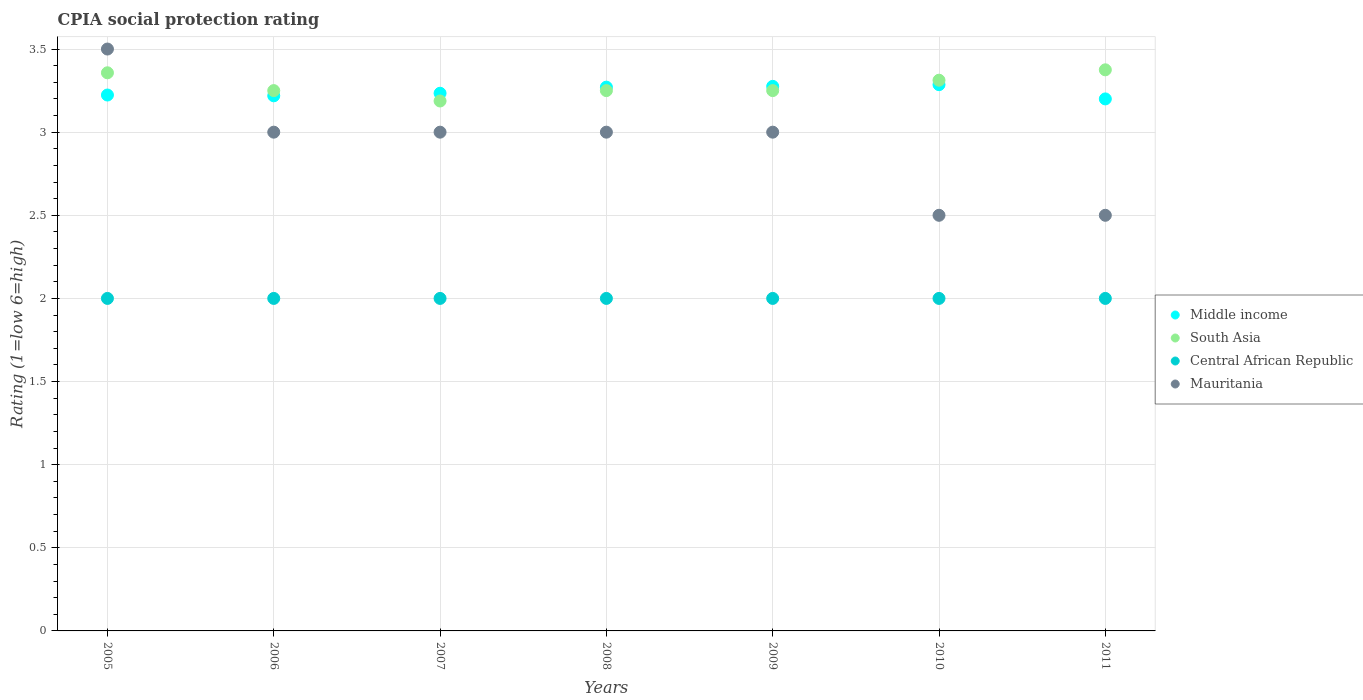How many different coloured dotlines are there?
Provide a succinct answer. 4. What is the CPIA rating in Mauritania in 2006?
Provide a short and direct response. 3. Across all years, what is the maximum CPIA rating in Middle income?
Keep it short and to the point. 3.29. In which year was the CPIA rating in Mauritania maximum?
Your answer should be very brief. 2005. What is the total CPIA rating in South Asia in the graph?
Offer a very short reply. 22.98. What is the difference between the CPIA rating in South Asia in 2009 and that in 2010?
Ensure brevity in your answer.  -0.06. What is the average CPIA rating in South Asia per year?
Provide a short and direct response. 3.28. In the year 2008, what is the difference between the CPIA rating in South Asia and CPIA rating in Middle income?
Provide a succinct answer. -0.02. What is the ratio of the CPIA rating in Central African Republic in 2005 to that in 2011?
Your response must be concise. 1. What is the difference between the highest and the second highest CPIA rating in Mauritania?
Your answer should be very brief. 0.5. What is the difference between the highest and the lowest CPIA rating in South Asia?
Ensure brevity in your answer.  0.19. Is the sum of the CPIA rating in Mauritania in 2006 and 2010 greater than the maximum CPIA rating in South Asia across all years?
Ensure brevity in your answer.  Yes. Is it the case that in every year, the sum of the CPIA rating in Central African Republic and CPIA rating in Mauritania  is greater than the sum of CPIA rating in South Asia and CPIA rating in Middle income?
Make the answer very short. No. Is it the case that in every year, the sum of the CPIA rating in Central African Republic and CPIA rating in Mauritania  is greater than the CPIA rating in South Asia?
Offer a very short reply. Yes. Is the CPIA rating in Mauritania strictly greater than the CPIA rating in Middle income over the years?
Provide a succinct answer. No. Is the CPIA rating in Middle income strictly less than the CPIA rating in South Asia over the years?
Provide a short and direct response. No. Are the values on the major ticks of Y-axis written in scientific E-notation?
Give a very brief answer. No. Where does the legend appear in the graph?
Provide a short and direct response. Center right. How many legend labels are there?
Provide a succinct answer. 4. How are the legend labels stacked?
Offer a very short reply. Vertical. What is the title of the graph?
Offer a terse response. CPIA social protection rating. What is the Rating (1=low 6=high) of Middle income in 2005?
Make the answer very short. 3.22. What is the Rating (1=low 6=high) of South Asia in 2005?
Ensure brevity in your answer.  3.36. What is the Rating (1=low 6=high) in Mauritania in 2005?
Your response must be concise. 3.5. What is the Rating (1=low 6=high) of Middle income in 2006?
Provide a short and direct response. 3.22. What is the Rating (1=low 6=high) of Central African Republic in 2006?
Ensure brevity in your answer.  2. What is the Rating (1=low 6=high) in Middle income in 2007?
Provide a succinct answer. 3.23. What is the Rating (1=low 6=high) in South Asia in 2007?
Ensure brevity in your answer.  3.19. What is the Rating (1=low 6=high) in Central African Republic in 2007?
Your answer should be very brief. 2. What is the Rating (1=low 6=high) in Middle income in 2008?
Make the answer very short. 3.27. What is the Rating (1=low 6=high) in South Asia in 2008?
Keep it short and to the point. 3.25. What is the Rating (1=low 6=high) in Central African Republic in 2008?
Provide a succinct answer. 2. What is the Rating (1=low 6=high) of Mauritania in 2008?
Your answer should be very brief. 3. What is the Rating (1=low 6=high) in Middle income in 2009?
Ensure brevity in your answer.  3.28. What is the Rating (1=low 6=high) in Middle income in 2010?
Keep it short and to the point. 3.29. What is the Rating (1=low 6=high) in South Asia in 2010?
Provide a succinct answer. 3.31. What is the Rating (1=low 6=high) in South Asia in 2011?
Provide a short and direct response. 3.38. What is the Rating (1=low 6=high) of Central African Republic in 2011?
Offer a terse response. 2. What is the Rating (1=low 6=high) of Mauritania in 2011?
Offer a terse response. 2.5. Across all years, what is the maximum Rating (1=low 6=high) of Middle income?
Your answer should be very brief. 3.29. Across all years, what is the maximum Rating (1=low 6=high) of South Asia?
Your answer should be very brief. 3.38. Across all years, what is the minimum Rating (1=low 6=high) in Middle income?
Provide a short and direct response. 3.2. Across all years, what is the minimum Rating (1=low 6=high) of South Asia?
Keep it short and to the point. 3.19. Across all years, what is the minimum Rating (1=low 6=high) in Mauritania?
Offer a terse response. 2.5. What is the total Rating (1=low 6=high) of Middle income in the graph?
Your response must be concise. 22.71. What is the total Rating (1=low 6=high) in South Asia in the graph?
Provide a succinct answer. 22.98. What is the total Rating (1=low 6=high) of Central African Republic in the graph?
Provide a short and direct response. 14. What is the total Rating (1=low 6=high) of Mauritania in the graph?
Offer a very short reply. 20.5. What is the difference between the Rating (1=low 6=high) in Middle income in 2005 and that in 2006?
Offer a terse response. 0. What is the difference between the Rating (1=low 6=high) in South Asia in 2005 and that in 2006?
Your answer should be compact. 0.11. What is the difference between the Rating (1=low 6=high) of Middle income in 2005 and that in 2007?
Offer a terse response. -0.01. What is the difference between the Rating (1=low 6=high) in South Asia in 2005 and that in 2007?
Ensure brevity in your answer.  0.17. What is the difference between the Rating (1=low 6=high) in Middle income in 2005 and that in 2008?
Your answer should be compact. -0.05. What is the difference between the Rating (1=low 6=high) in South Asia in 2005 and that in 2008?
Make the answer very short. 0.11. What is the difference between the Rating (1=low 6=high) in Central African Republic in 2005 and that in 2008?
Keep it short and to the point. 0. What is the difference between the Rating (1=low 6=high) in Middle income in 2005 and that in 2009?
Make the answer very short. -0.05. What is the difference between the Rating (1=low 6=high) of South Asia in 2005 and that in 2009?
Make the answer very short. 0.11. What is the difference between the Rating (1=low 6=high) of Central African Republic in 2005 and that in 2009?
Provide a succinct answer. 0. What is the difference between the Rating (1=low 6=high) in Mauritania in 2005 and that in 2009?
Give a very brief answer. 0.5. What is the difference between the Rating (1=low 6=high) of Middle income in 2005 and that in 2010?
Keep it short and to the point. -0.06. What is the difference between the Rating (1=low 6=high) of South Asia in 2005 and that in 2010?
Offer a terse response. 0.04. What is the difference between the Rating (1=low 6=high) of Central African Republic in 2005 and that in 2010?
Ensure brevity in your answer.  0. What is the difference between the Rating (1=low 6=high) of Mauritania in 2005 and that in 2010?
Your answer should be very brief. 1. What is the difference between the Rating (1=low 6=high) of Middle income in 2005 and that in 2011?
Offer a very short reply. 0.02. What is the difference between the Rating (1=low 6=high) of South Asia in 2005 and that in 2011?
Ensure brevity in your answer.  -0.02. What is the difference between the Rating (1=low 6=high) in Central African Republic in 2005 and that in 2011?
Ensure brevity in your answer.  0. What is the difference between the Rating (1=low 6=high) in Middle income in 2006 and that in 2007?
Keep it short and to the point. -0.02. What is the difference between the Rating (1=low 6=high) in South Asia in 2006 and that in 2007?
Offer a terse response. 0.06. What is the difference between the Rating (1=low 6=high) of Mauritania in 2006 and that in 2007?
Provide a short and direct response. 0. What is the difference between the Rating (1=low 6=high) in Middle income in 2006 and that in 2008?
Make the answer very short. -0.05. What is the difference between the Rating (1=low 6=high) of Central African Republic in 2006 and that in 2008?
Offer a very short reply. 0. What is the difference between the Rating (1=low 6=high) of Mauritania in 2006 and that in 2008?
Give a very brief answer. 0. What is the difference between the Rating (1=low 6=high) of Middle income in 2006 and that in 2009?
Give a very brief answer. -0.06. What is the difference between the Rating (1=low 6=high) of South Asia in 2006 and that in 2009?
Keep it short and to the point. 0. What is the difference between the Rating (1=low 6=high) in Mauritania in 2006 and that in 2009?
Provide a short and direct response. 0. What is the difference between the Rating (1=low 6=high) in Middle income in 2006 and that in 2010?
Offer a terse response. -0.07. What is the difference between the Rating (1=low 6=high) of South Asia in 2006 and that in 2010?
Your answer should be very brief. -0.06. What is the difference between the Rating (1=low 6=high) in Middle income in 2006 and that in 2011?
Ensure brevity in your answer.  0.02. What is the difference between the Rating (1=low 6=high) in South Asia in 2006 and that in 2011?
Keep it short and to the point. -0.12. What is the difference between the Rating (1=low 6=high) in Central African Republic in 2006 and that in 2011?
Your answer should be very brief. 0. What is the difference between the Rating (1=low 6=high) in Middle income in 2007 and that in 2008?
Your answer should be compact. -0.04. What is the difference between the Rating (1=low 6=high) of South Asia in 2007 and that in 2008?
Give a very brief answer. -0.06. What is the difference between the Rating (1=low 6=high) in Central African Republic in 2007 and that in 2008?
Provide a short and direct response. 0. What is the difference between the Rating (1=low 6=high) in Middle income in 2007 and that in 2009?
Ensure brevity in your answer.  -0.04. What is the difference between the Rating (1=low 6=high) of South Asia in 2007 and that in 2009?
Ensure brevity in your answer.  -0.06. What is the difference between the Rating (1=low 6=high) of Mauritania in 2007 and that in 2009?
Keep it short and to the point. 0. What is the difference between the Rating (1=low 6=high) in Middle income in 2007 and that in 2010?
Provide a succinct answer. -0.05. What is the difference between the Rating (1=low 6=high) in South Asia in 2007 and that in 2010?
Provide a short and direct response. -0.12. What is the difference between the Rating (1=low 6=high) in Central African Republic in 2007 and that in 2010?
Provide a succinct answer. 0. What is the difference between the Rating (1=low 6=high) of Mauritania in 2007 and that in 2010?
Provide a succinct answer. 0.5. What is the difference between the Rating (1=low 6=high) in Middle income in 2007 and that in 2011?
Your answer should be compact. 0.03. What is the difference between the Rating (1=low 6=high) of South Asia in 2007 and that in 2011?
Offer a terse response. -0.19. What is the difference between the Rating (1=low 6=high) of Mauritania in 2007 and that in 2011?
Your response must be concise. 0.5. What is the difference between the Rating (1=low 6=high) in Middle income in 2008 and that in 2009?
Provide a succinct answer. -0. What is the difference between the Rating (1=low 6=high) of South Asia in 2008 and that in 2009?
Offer a terse response. 0. What is the difference between the Rating (1=low 6=high) in Central African Republic in 2008 and that in 2009?
Your answer should be very brief. 0. What is the difference between the Rating (1=low 6=high) in Middle income in 2008 and that in 2010?
Provide a short and direct response. -0.01. What is the difference between the Rating (1=low 6=high) of South Asia in 2008 and that in 2010?
Your answer should be compact. -0.06. What is the difference between the Rating (1=low 6=high) of Central African Republic in 2008 and that in 2010?
Make the answer very short. 0. What is the difference between the Rating (1=low 6=high) of Middle income in 2008 and that in 2011?
Your response must be concise. 0.07. What is the difference between the Rating (1=low 6=high) in South Asia in 2008 and that in 2011?
Your answer should be compact. -0.12. What is the difference between the Rating (1=low 6=high) in Middle income in 2009 and that in 2010?
Offer a very short reply. -0.01. What is the difference between the Rating (1=low 6=high) of South Asia in 2009 and that in 2010?
Provide a succinct answer. -0.06. What is the difference between the Rating (1=low 6=high) in Central African Republic in 2009 and that in 2010?
Provide a succinct answer. 0. What is the difference between the Rating (1=low 6=high) in Mauritania in 2009 and that in 2010?
Provide a short and direct response. 0.5. What is the difference between the Rating (1=low 6=high) in Middle income in 2009 and that in 2011?
Provide a succinct answer. 0.08. What is the difference between the Rating (1=low 6=high) in South Asia in 2009 and that in 2011?
Offer a very short reply. -0.12. What is the difference between the Rating (1=low 6=high) of Central African Republic in 2009 and that in 2011?
Your answer should be compact. 0. What is the difference between the Rating (1=low 6=high) of Middle income in 2010 and that in 2011?
Your answer should be compact. 0.09. What is the difference between the Rating (1=low 6=high) in South Asia in 2010 and that in 2011?
Your answer should be very brief. -0.06. What is the difference between the Rating (1=low 6=high) of Central African Republic in 2010 and that in 2011?
Your answer should be very brief. 0. What is the difference between the Rating (1=low 6=high) in Mauritania in 2010 and that in 2011?
Give a very brief answer. 0. What is the difference between the Rating (1=low 6=high) of Middle income in 2005 and the Rating (1=low 6=high) of South Asia in 2006?
Provide a succinct answer. -0.03. What is the difference between the Rating (1=low 6=high) in Middle income in 2005 and the Rating (1=low 6=high) in Central African Republic in 2006?
Make the answer very short. 1.22. What is the difference between the Rating (1=low 6=high) in Middle income in 2005 and the Rating (1=low 6=high) in Mauritania in 2006?
Offer a very short reply. 0.22. What is the difference between the Rating (1=low 6=high) in South Asia in 2005 and the Rating (1=low 6=high) in Central African Republic in 2006?
Offer a very short reply. 1.36. What is the difference between the Rating (1=low 6=high) of South Asia in 2005 and the Rating (1=low 6=high) of Mauritania in 2006?
Give a very brief answer. 0.36. What is the difference between the Rating (1=low 6=high) of Central African Republic in 2005 and the Rating (1=low 6=high) of Mauritania in 2006?
Your answer should be compact. -1. What is the difference between the Rating (1=low 6=high) in Middle income in 2005 and the Rating (1=low 6=high) in South Asia in 2007?
Provide a succinct answer. 0.04. What is the difference between the Rating (1=low 6=high) in Middle income in 2005 and the Rating (1=low 6=high) in Central African Republic in 2007?
Your answer should be very brief. 1.22. What is the difference between the Rating (1=low 6=high) of Middle income in 2005 and the Rating (1=low 6=high) of Mauritania in 2007?
Provide a succinct answer. 0.22. What is the difference between the Rating (1=low 6=high) in South Asia in 2005 and the Rating (1=low 6=high) in Central African Republic in 2007?
Provide a succinct answer. 1.36. What is the difference between the Rating (1=low 6=high) of South Asia in 2005 and the Rating (1=low 6=high) of Mauritania in 2007?
Provide a succinct answer. 0.36. What is the difference between the Rating (1=low 6=high) in Middle income in 2005 and the Rating (1=low 6=high) in South Asia in 2008?
Offer a very short reply. -0.03. What is the difference between the Rating (1=low 6=high) in Middle income in 2005 and the Rating (1=low 6=high) in Central African Republic in 2008?
Give a very brief answer. 1.22. What is the difference between the Rating (1=low 6=high) of Middle income in 2005 and the Rating (1=low 6=high) of Mauritania in 2008?
Your answer should be compact. 0.22. What is the difference between the Rating (1=low 6=high) in South Asia in 2005 and the Rating (1=low 6=high) in Central African Republic in 2008?
Your response must be concise. 1.36. What is the difference between the Rating (1=low 6=high) in South Asia in 2005 and the Rating (1=low 6=high) in Mauritania in 2008?
Provide a succinct answer. 0.36. What is the difference between the Rating (1=low 6=high) in Middle income in 2005 and the Rating (1=low 6=high) in South Asia in 2009?
Your response must be concise. -0.03. What is the difference between the Rating (1=low 6=high) of Middle income in 2005 and the Rating (1=low 6=high) of Central African Republic in 2009?
Provide a succinct answer. 1.22. What is the difference between the Rating (1=low 6=high) in Middle income in 2005 and the Rating (1=low 6=high) in Mauritania in 2009?
Your answer should be very brief. 0.22. What is the difference between the Rating (1=low 6=high) in South Asia in 2005 and the Rating (1=low 6=high) in Central African Republic in 2009?
Give a very brief answer. 1.36. What is the difference between the Rating (1=low 6=high) in South Asia in 2005 and the Rating (1=low 6=high) in Mauritania in 2009?
Offer a very short reply. 0.36. What is the difference between the Rating (1=low 6=high) in Central African Republic in 2005 and the Rating (1=low 6=high) in Mauritania in 2009?
Offer a very short reply. -1. What is the difference between the Rating (1=low 6=high) in Middle income in 2005 and the Rating (1=low 6=high) in South Asia in 2010?
Your response must be concise. -0.09. What is the difference between the Rating (1=low 6=high) of Middle income in 2005 and the Rating (1=low 6=high) of Central African Republic in 2010?
Give a very brief answer. 1.22. What is the difference between the Rating (1=low 6=high) of Middle income in 2005 and the Rating (1=low 6=high) of Mauritania in 2010?
Give a very brief answer. 0.72. What is the difference between the Rating (1=low 6=high) in South Asia in 2005 and the Rating (1=low 6=high) in Central African Republic in 2010?
Your response must be concise. 1.36. What is the difference between the Rating (1=low 6=high) in South Asia in 2005 and the Rating (1=low 6=high) in Mauritania in 2010?
Your answer should be very brief. 0.86. What is the difference between the Rating (1=low 6=high) of Middle income in 2005 and the Rating (1=low 6=high) of South Asia in 2011?
Your response must be concise. -0.15. What is the difference between the Rating (1=low 6=high) of Middle income in 2005 and the Rating (1=low 6=high) of Central African Republic in 2011?
Your answer should be compact. 1.22. What is the difference between the Rating (1=low 6=high) in Middle income in 2005 and the Rating (1=low 6=high) in Mauritania in 2011?
Give a very brief answer. 0.72. What is the difference between the Rating (1=low 6=high) in South Asia in 2005 and the Rating (1=low 6=high) in Central African Republic in 2011?
Your answer should be compact. 1.36. What is the difference between the Rating (1=low 6=high) of Central African Republic in 2005 and the Rating (1=low 6=high) of Mauritania in 2011?
Offer a terse response. -0.5. What is the difference between the Rating (1=low 6=high) in Middle income in 2006 and the Rating (1=low 6=high) in South Asia in 2007?
Your response must be concise. 0.03. What is the difference between the Rating (1=low 6=high) in Middle income in 2006 and the Rating (1=low 6=high) in Central African Republic in 2007?
Give a very brief answer. 1.22. What is the difference between the Rating (1=low 6=high) in Middle income in 2006 and the Rating (1=low 6=high) in Mauritania in 2007?
Your response must be concise. 0.22. What is the difference between the Rating (1=low 6=high) of South Asia in 2006 and the Rating (1=low 6=high) of Mauritania in 2007?
Give a very brief answer. 0.25. What is the difference between the Rating (1=low 6=high) of Middle income in 2006 and the Rating (1=low 6=high) of South Asia in 2008?
Your answer should be compact. -0.03. What is the difference between the Rating (1=low 6=high) in Middle income in 2006 and the Rating (1=low 6=high) in Central African Republic in 2008?
Your answer should be compact. 1.22. What is the difference between the Rating (1=low 6=high) in Middle income in 2006 and the Rating (1=low 6=high) in Mauritania in 2008?
Keep it short and to the point. 0.22. What is the difference between the Rating (1=low 6=high) of South Asia in 2006 and the Rating (1=low 6=high) of Central African Republic in 2008?
Your answer should be very brief. 1.25. What is the difference between the Rating (1=low 6=high) in Central African Republic in 2006 and the Rating (1=low 6=high) in Mauritania in 2008?
Your answer should be compact. -1. What is the difference between the Rating (1=low 6=high) of Middle income in 2006 and the Rating (1=low 6=high) of South Asia in 2009?
Provide a short and direct response. -0.03. What is the difference between the Rating (1=low 6=high) in Middle income in 2006 and the Rating (1=low 6=high) in Central African Republic in 2009?
Your response must be concise. 1.22. What is the difference between the Rating (1=low 6=high) of Middle income in 2006 and the Rating (1=low 6=high) of Mauritania in 2009?
Your response must be concise. 0.22. What is the difference between the Rating (1=low 6=high) in South Asia in 2006 and the Rating (1=low 6=high) in Mauritania in 2009?
Give a very brief answer. 0.25. What is the difference between the Rating (1=low 6=high) in Central African Republic in 2006 and the Rating (1=low 6=high) in Mauritania in 2009?
Provide a succinct answer. -1. What is the difference between the Rating (1=low 6=high) in Middle income in 2006 and the Rating (1=low 6=high) in South Asia in 2010?
Offer a very short reply. -0.09. What is the difference between the Rating (1=low 6=high) of Middle income in 2006 and the Rating (1=low 6=high) of Central African Republic in 2010?
Ensure brevity in your answer.  1.22. What is the difference between the Rating (1=low 6=high) of Middle income in 2006 and the Rating (1=low 6=high) of Mauritania in 2010?
Provide a succinct answer. 0.72. What is the difference between the Rating (1=low 6=high) of Central African Republic in 2006 and the Rating (1=low 6=high) of Mauritania in 2010?
Offer a terse response. -0.5. What is the difference between the Rating (1=low 6=high) in Middle income in 2006 and the Rating (1=low 6=high) in South Asia in 2011?
Ensure brevity in your answer.  -0.16. What is the difference between the Rating (1=low 6=high) of Middle income in 2006 and the Rating (1=low 6=high) of Central African Republic in 2011?
Provide a short and direct response. 1.22. What is the difference between the Rating (1=low 6=high) in Middle income in 2006 and the Rating (1=low 6=high) in Mauritania in 2011?
Give a very brief answer. 0.72. What is the difference between the Rating (1=low 6=high) in South Asia in 2006 and the Rating (1=low 6=high) in Central African Republic in 2011?
Your answer should be very brief. 1.25. What is the difference between the Rating (1=low 6=high) in South Asia in 2006 and the Rating (1=low 6=high) in Mauritania in 2011?
Ensure brevity in your answer.  0.75. What is the difference between the Rating (1=low 6=high) in Middle income in 2007 and the Rating (1=low 6=high) in South Asia in 2008?
Provide a short and direct response. -0.02. What is the difference between the Rating (1=low 6=high) in Middle income in 2007 and the Rating (1=low 6=high) in Central African Republic in 2008?
Make the answer very short. 1.23. What is the difference between the Rating (1=low 6=high) of Middle income in 2007 and the Rating (1=low 6=high) of Mauritania in 2008?
Offer a terse response. 0.23. What is the difference between the Rating (1=low 6=high) in South Asia in 2007 and the Rating (1=low 6=high) in Central African Republic in 2008?
Your answer should be compact. 1.19. What is the difference between the Rating (1=low 6=high) of South Asia in 2007 and the Rating (1=low 6=high) of Mauritania in 2008?
Ensure brevity in your answer.  0.19. What is the difference between the Rating (1=low 6=high) in Middle income in 2007 and the Rating (1=low 6=high) in South Asia in 2009?
Provide a succinct answer. -0.02. What is the difference between the Rating (1=low 6=high) of Middle income in 2007 and the Rating (1=low 6=high) of Central African Republic in 2009?
Provide a short and direct response. 1.23. What is the difference between the Rating (1=low 6=high) in Middle income in 2007 and the Rating (1=low 6=high) in Mauritania in 2009?
Provide a short and direct response. 0.23. What is the difference between the Rating (1=low 6=high) in South Asia in 2007 and the Rating (1=low 6=high) in Central African Republic in 2009?
Your answer should be very brief. 1.19. What is the difference between the Rating (1=low 6=high) of South Asia in 2007 and the Rating (1=low 6=high) of Mauritania in 2009?
Your answer should be very brief. 0.19. What is the difference between the Rating (1=low 6=high) in Central African Republic in 2007 and the Rating (1=low 6=high) in Mauritania in 2009?
Provide a succinct answer. -1. What is the difference between the Rating (1=low 6=high) in Middle income in 2007 and the Rating (1=low 6=high) in South Asia in 2010?
Provide a succinct answer. -0.08. What is the difference between the Rating (1=low 6=high) of Middle income in 2007 and the Rating (1=low 6=high) of Central African Republic in 2010?
Provide a succinct answer. 1.23. What is the difference between the Rating (1=low 6=high) of Middle income in 2007 and the Rating (1=low 6=high) of Mauritania in 2010?
Provide a succinct answer. 0.73. What is the difference between the Rating (1=low 6=high) in South Asia in 2007 and the Rating (1=low 6=high) in Central African Republic in 2010?
Your response must be concise. 1.19. What is the difference between the Rating (1=low 6=high) of South Asia in 2007 and the Rating (1=low 6=high) of Mauritania in 2010?
Your response must be concise. 0.69. What is the difference between the Rating (1=low 6=high) of Central African Republic in 2007 and the Rating (1=low 6=high) of Mauritania in 2010?
Provide a succinct answer. -0.5. What is the difference between the Rating (1=low 6=high) of Middle income in 2007 and the Rating (1=low 6=high) of South Asia in 2011?
Your response must be concise. -0.14. What is the difference between the Rating (1=low 6=high) of Middle income in 2007 and the Rating (1=low 6=high) of Central African Republic in 2011?
Make the answer very short. 1.23. What is the difference between the Rating (1=low 6=high) of Middle income in 2007 and the Rating (1=low 6=high) of Mauritania in 2011?
Make the answer very short. 0.73. What is the difference between the Rating (1=low 6=high) in South Asia in 2007 and the Rating (1=low 6=high) in Central African Republic in 2011?
Your response must be concise. 1.19. What is the difference between the Rating (1=low 6=high) in South Asia in 2007 and the Rating (1=low 6=high) in Mauritania in 2011?
Your answer should be very brief. 0.69. What is the difference between the Rating (1=low 6=high) of Middle income in 2008 and the Rating (1=low 6=high) of South Asia in 2009?
Make the answer very short. 0.02. What is the difference between the Rating (1=low 6=high) in Middle income in 2008 and the Rating (1=low 6=high) in Central African Republic in 2009?
Your answer should be very brief. 1.27. What is the difference between the Rating (1=low 6=high) in Middle income in 2008 and the Rating (1=low 6=high) in Mauritania in 2009?
Ensure brevity in your answer.  0.27. What is the difference between the Rating (1=low 6=high) in South Asia in 2008 and the Rating (1=low 6=high) in Mauritania in 2009?
Keep it short and to the point. 0.25. What is the difference between the Rating (1=low 6=high) in Central African Republic in 2008 and the Rating (1=low 6=high) in Mauritania in 2009?
Provide a succinct answer. -1. What is the difference between the Rating (1=low 6=high) of Middle income in 2008 and the Rating (1=low 6=high) of South Asia in 2010?
Your response must be concise. -0.04. What is the difference between the Rating (1=low 6=high) of Middle income in 2008 and the Rating (1=low 6=high) of Central African Republic in 2010?
Give a very brief answer. 1.27. What is the difference between the Rating (1=low 6=high) of Middle income in 2008 and the Rating (1=low 6=high) of Mauritania in 2010?
Keep it short and to the point. 0.77. What is the difference between the Rating (1=low 6=high) in South Asia in 2008 and the Rating (1=low 6=high) in Central African Republic in 2010?
Your answer should be very brief. 1.25. What is the difference between the Rating (1=low 6=high) of South Asia in 2008 and the Rating (1=low 6=high) of Mauritania in 2010?
Make the answer very short. 0.75. What is the difference between the Rating (1=low 6=high) in Middle income in 2008 and the Rating (1=low 6=high) in South Asia in 2011?
Keep it short and to the point. -0.1. What is the difference between the Rating (1=low 6=high) in Middle income in 2008 and the Rating (1=low 6=high) in Central African Republic in 2011?
Your answer should be compact. 1.27. What is the difference between the Rating (1=low 6=high) of Middle income in 2008 and the Rating (1=low 6=high) of Mauritania in 2011?
Your answer should be compact. 0.77. What is the difference between the Rating (1=low 6=high) of South Asia in 2008 and the Rating (1=low 6=high) of Central African Republic in 2011?
Offer a very short reply. 1.25. What is the difference between the Rating (1=low 6=high) in South Asia in 2008 and the Rating (1=low 6=high) in Mauritania in 2011?
Offer a very short reply. 0.75. What is the difference between the Rating (1=low 6=high) of Middle income in 2009 and the Rating (1=low 6=high) of South Asia in 2010?
Your response must be concise. -0.04. What is the difference between the Rating (1=low 6=high) of Middle income in 2009 and the Rating (1=low 6=high) of Central African Republic in 2010?
Keep it short and to the point. 1.28. What is the difference between the Rating (1=low 6=high) of Middle income in 2009 and the Rating (1=low 6=high) of Mauritania in 2010?
Offer a terse response. 0.78. What is the difference between the Rating (1=low 6=high) in South Asia in 2009 and the Rating (1=low 6=high) in Central African Republic in 2010?
Your response must be concise. 1.25. What is the difference between the Rating (1=low 6=high) in South Asia in 2009 and the Rating (1=low 6=high) in Mauritania in 2010?
Provide a succinct answer. 0.75. What is the difference between the Rating (1=low 6=high) of Central African Republic in 2009 and the Rating (1=low 6=high) of Mauritania in 2010?
Offer a very short reply. -0.5. What is the difference between the Rating (1=low 6=high) in Middle income in 2009 and the Rating (1=low 6=high) in South Asia in 2011?
Provide a short and direct response. -0.1. What is the difference between the Rating (1=low 6=high) in Middle income in 2009 and the Rating (1=low 6=high) in Central African Republic in 2011?
Provide a succinct answer. 1.28. What is the difference between the Rating (1=low 6=high) in Middle income in 2009 and the Rating (1=low 6=high) in Mauritania in 2011?
Your answer should be very brief. 0.78. What is the difference between the Rating (1=low 6=high) of South Asia in 2009 and the Rating (1=low 6=high) of Central African Republic in 2011?
Your answer should be compact. 1.25. What is the difference between the Rating (1=low 6=high) of Middle income in 2010 and the Rating (1=low 6=high) of South Asia in 2011?
Keep it short and to the point. -0.09. What is the difference between the Rating (1=low 6=high) in Middle income in 2010 and the Rating (1=low 6=high) in Mauritania in 2011?
Provide a short and direct response. 0.79. What is the difference between the Rating (1=low 6=high) in South Asia in 2010 and the Rating (1=low 6=high) in Central African Republic in 2011?
Ensure brevity in your answer.  1.31. What is the difference between the Rating (1=low 6=high) in South Asia in 2010 and the Rating (1=low 6=high) in Mauritania in 2011?
Make the answer very short. 0.81. What is the average Rating (1=low 6=high) in Middle income per year?
Make the answer very short. 3.24. What is the average Rating (1=low 6=high) in South Asia per year?
Offer a very short reply. 3.28. What is the average Rating (1=low 6=high) of Mauritania per year?
Your answer should be very brief. 2.93. In the year 2005, what is the difference between the Rating (1=low 6=high) in Middle income and Rating (1=low 6=high) in South Asia?
Provide a succinct answer. -0.13. In the year 2005, what is the difference between the Rating (1=low 6=high) of Middle income and Rating (1=low 6=high) of Central African Republic?
Your response must be concise. 1.22. In the year 2005, what is the difference between the Rating (1=low 6=high) in Middle income and Rating (1=low 6=high) in Mauritania?
Your response must be concise. -0.28. In the year 2005, what is the difference between the Rating (1=low 6=high) of South Asia and Rating (1=low 6=high) of Central African Republic?
Offer a very short reply. 1.36. In the year 2005, what is the difference between the Rating (1=low 6=high) of South Asia and Rating (1=low 6=high) of Mauritania?
Give a very brief answer. -0.14. In the year 2006, what is the difference between the Rating (1=low 6=high) in Middle income and Rating (1=low 6=high) in South Asia?
Provide a succinct answer. -0.03. In the year 2006, what is the difference between the Rating (1=low 6=high) in Middle income and Rating (1=low 6=high) in Central African Republic?
Provide a short and direct response. 1.22. In the year 2006, what is the difference between the Rating (1=low 6=high) of Middle income and Rating (1=low 6=high) of Mauritania?
Offer a terse response. 0.22. In the year 2006, what is the difference between the Rating (1=low 6=high) of Central African Republic and Rating (1=low 6=high) of Mauritania?
Your answer should be very brief. -1. In the year 2007, what is the difference between the Rating (1=low 6=high) of Middle income and Rating (1=low 6=high) of South Asia?
Your answer should be very brief. 0.05. In the year 2007, what is the difference between the Rating (1=low 6=high) of Middle income and Rating (1=low 6=high) of Central African Republic?
Offer a very short reply. 1.23. In the year 2007, what is the difference between the Rating (1=low 6=high) in Middle income and Rating (1=low 6=high) in Mauritania?
Make the answer very short. 0.23. In the year 2007, what is the difference between the Rating (1=low 6=high) in South Asia and Rating (1=low 6=high) in Central African Republic?
Make the answer very short. 1.19. In the year 2007, what is the difference between the Rating (1=low 6=high) of South Asia and Rating (1=low 6=high) of Mauritania?
Ensure brevity in your answer.  0.19. In the year 2007, what is the difference between the Rating (1=low 6=high) in Central African Republic and Rating (1=low 6=high) in Mauritania?
Keep it short and to the point. -1. In the year 2008, what is the difference between the Rating (1=low 6=high) in Middle income and Rating (1=low 6=high) in South Asia?
Your answer should be very brief. 0.02. In the year 2008, what is the difference between the Rating (1=low 6=high) of Middle income and Rating (1=low 6=high) of Central African Republic?
Make the answer very short. 1.27. In the year 2008, what is the difference between the Rating (1=low 6=high) of Middle income and Rating (1=low 6=high) of Mauritania?
Your answer should be very brief. 0.27. In the year 2008, what is the difference between the Rating (1=low 6=high) in South Asia and Rating (1=low 6=high) in Central African Republic?
Your response must be concise. 1.25. In the year 2009, what is the difference between the Rating (1=low 6=high) of Middle income and Rating (1=low 6=high) of South Asia?
Your answer should be very brief. 0.03. In the year 2009, what is the difference between the Rating (1=low 6=high) of Middle income and Rating (1=low 6=high) of Central African Republic?
Your answer should be very brief. 1.28. In the year 2009, what is the difference between the Rating (1=low 6=high) in Middle income and Rating (1=low 6=high) in Mauritania?
Keep it short and to the point. 0.28. In the year 2009, what is the difference between the Rating (1=low 6=high) in South Asia and Rating (1=low 6=high) in Central African Republic?
Make the answer very short. 1.25. In the year 2009, what is the difference between the Rating (1=low 6=high) of South Asia and Rating (1=low 6=high) of Mauritania?
Make the answer very short. 0.25. In the year 2010, what is the difference between the Rating (1=low 6=high) in Middle income and Rating (1=low 6=high) in South Asia?
Make the answer very short. -0.03. In the year 2010, what is the difference between the Rating (1=low 6=high) in Middle income and Rating (1=low 6=high) in Mauritania?
Offer a very short reply. 0.79. In the year 2010, what is the difference between the Rating (1=low 6=high) in South Asia and Rating (1=low 6=high) in Central African Republic?
Offer a terse response. 1.31. In the year 2010, what is the difference between the Rating (1=low 6=high) of South Asia and Rating (1=low 6=high) of Mauritania?
Ensure brevity in your answer.  0.81. In the year 2011, what is the difference between the Rating (1=low 6=high) in Middle income and Rating (1=low 6=high) in South Asia?
Offer a terse response. -0.17. In the year 2011, what is the difference between the Rating (1=low 6=high) in Middle income and Rating (1=low 6=high) in Central African Republic?
Offer a very short reply. 1.2. In the year 2011, what is the difference between the Rating (1=low 6=high) of South Asia and Rating (1=low 6=high) of Central African Republic?
Your answer should be compact. 1.38. In the year 2011, what is the difference between the Rating (1=low 6=high) in South Asia and Rating (1=low 6=high) in Mauritania?
Make the answer very short. 0.88. In the year 2011, what is the difference between the Rating (1=low 6=high) in Central African Republic and Rating (1=low 6=high) in Mauritania?
Your response must be concise. -0.5. What is the ratio of the Rating (1=low 6=high) of South Asia in 2005 to that in 2006?
Offer a very short reply. 1.03. What is the ratio of the Rating (1=low 6=high) of Mauritania in 2005 to that in 2006?
Give a very brief answer. 1.17. What is the ratio of the Rating (1=low 6=high) in South Asia in 2005 to that in 2007?
Your response must be concise. 1.05. What is the ratio of the Rating (1=low 6=high) of Mauritania in 2005 to that in 2007?
Offer a terse response. 1.17. What is the ratio of the Rating (1=low 6=high) in Middle income in 2005 to that in 2008?
Ensure brevity in your answer.  0.99. What is the ratio of the Rating (1=low 6=high) of South Asia in 2005 to that in 2008?
Provide a short and direct response. 1.03. What is the ratio of the Rating (1=low 6=high) of Central African Republic in 2005 to that in 2008?
Offer a very short reply. 1. What is the ratio of the Rating (1=low 6=high) in Mauritania in 2005 to that in 2008?
Your answer should be very brief. 1.17. What is the ratio of the Rating (1=low 6=high) in Middle income in 2005 to that in 2009?
Provide a succinct answer. 0.98. What is the ratio of the Rating (1=low 6=high) in South Asia in 2005 to that in 2009?
Keep it short and to the point. 1.03. What is the ratio of the Rating (1=low 6=high) of Mauritania in 2005 to that in 2009?
Ensure brevity in your answer.  1.17. What is the ratio of the Rating (1=low 6=high) in Middle income in 2005 to that in 2010?
Provide a short and direct response. 0.98. What is the ratio of the Rating (1=low 6=high) in South Asia in 2005 to that in 2010?
Offer a terse response. 1.01. What is the ratio of the Rating (1=low 6=high) of Middle income in 2005 to that in 2011?
Your answer should be very brief. 1.01. What is the ratio of the Rating (1=low 6=high) in South Asia in 2005 to that in 2011?
Make the answer very short. 0.99. What is the ratio of the Rating (1=low 6=high) in Mauritania in 2005 to that in 2011?
Provide a succinct answer. 1.4. What is the ratio of the Rating (1=low 6=high) in South Asia in 2006 to that in 2007?
Your response must be concise. 1.02. What is the ratio of the Rating (1=low 6=high) in Mauritania in 2006 to that in 2007?
Keep it short and to the point. 1. What is the ratio of the Rating (1=low 6=high) of Middle income in 2006 to that in 2008?
Ensure brevity in your answer.  0.98. What is the ratio of the Rating (1=low 6=high) of South Asia in 2006 to that in 2008?
Ensure brevity in your answer.  1. What is the ratio of the Rating (1=low 6=high) of Central African Republic in 2006 to that in 2008?
Offer a terse response. 1. What is the ratio of the Rating (1=low 6=high) in Middle income in 2006 to that in 2009?
Your answer should be very brief. 0.98. What is the ratio of the Rating (1=low 6=high) of Mauritania in 2006 to that in 2009?
Offer a terse response. 1. What is the ratio of the Rating (1=low 6=high) of Middle income in 2006 to that in 2010?
Ensure brevity in your answer.  0.98. What is the ratio of the Rating (1=low 6=high) of South Asia in 2006 to that in 2010?
Give a very brief answer. 0.98. What is the ratio of the Rating (1=low 6=high) of Mauritania in 2006 to that in 2010?
Your answer should be very brief. 1.2. What is the ratio of the Rating (1=low 6=high) in Middle income in 2006 to that in 2011?
Provide a succinct answer. 1.01. What is the ratio of the Rating (1=low 6=high) of Central African Republic in 2006 to that in 2011?
Your response must be concise. 1. What is the ratio of the Rating (1=low 6=high) in South Asia in 2007 to that in 2008?
Provide a succinct answer. 0.98. What is the ratio of the Rating (1=low 6=high) of Middle income in 2007 to that in 2009?
Offer a terse response. 0.99. What is the ratio of the Rating (1=low 6=high) in South Asia in 2007 to that in 2009?
Give a very brief answer. 0.98. What is the ratio of the Rating (1=low 6=high) of Central African Republic in 2007 to that in 2009?
Make the answer very short. 1. What is the ratio of the Rating (1=low 6=high) in Middle income in 2007 to that in 2010?
Your answer should be very brief. 0.98. What is the ratio of the Rating (1=low 6=high) of South Asia in 2007 to that in 2010?
Provide a short and direct response. 0.96. What is the ratio of the Rating (1=low 6=high) in Central African Republic in 2007 to that in 2010?
Make the answer very short. 1. What is the ratio of the Rating (1=low 6=high) in Mauritania in 2007 to that in 2010?
Give a very brief answer. 1.2. What is the ratio of the Rating (1=low 6=high) of Middle income in 2007 to that in 2011?
Offer a very short reply. 1.01. What is the ratio of the Rating (1=low 6=high) in South Asia in 2007 to that in 2011?
Give a very brief answer. 0.94. What is the ratio of the Rating (1=low 6=high) of Mauritania in 2007 to that in 2011?
Offer a terse response. 1.2. What is the ratio of the Rating (1=low 6=high) of Middle income in 2008 to that in 2009?
Make the answer very short. 1. What is the ratio of the Rating (1=low 6=high) in Central African Republic in 2008 to that in 2009?
Ensure brevity in your answer.  1. What is the ratio of the Rating (1=low 6=high) of Mauritania in 2008 to that in 2009?
Make the answer very short. 1. What is the ratio of the Rating (1=low 6=high) in Middle income in 2008 to that in 2010?
Keep it short and to the point. 1. What is the ratio of the Rating (1=low 6=high) in South Asia in 2008 to that in 2010?
Your answer should be compact. 0.98. What is the ratio of the Rating (1=low 6=high) in Middle income in 2008 to that in 2011?
Offer a terse response. 1.02. What is the ratio of the Rating (1=low 6=high) of Central African Republic in 2008 to that in 2011?
Offer a terse response. 1. What is the ratio of the Rating (1=low 6=high) in South Asia in 2009 to that in 2010?
Offer a very short reply. 0.98. What is the ratio of the Rating (1=low 6=high) in Central African Republic in 2009 to that in 2010?
Offer a very short reply. 1. What is the ratio of the Rating (1=low 6=high) in Middle income in 2009 to that in 2011?
Ensure brevity in your answer.  1.02. What is the ratio of the Rating (1=low 6=high) in Mauritania in 2009 to that in 2011?
Your response must be concise. 1.2. What is the ratio of the Rating (1=low 6=high) in Middle income in 2010 to that in 2011?
Ensure brevity in your answer.  1.03. What is the ratio of the Rating (1=low 6=high) in South Asia in 2010 to that in 2011?
Your response must be concise. 0.98. What is the ratio of the Rating (1=low 6=high) in Mauritania in 2010 to that in 2011?
Ensure brevity in your answer.  1. What is the difference between the highest and the second highest Rating (1=low 6=high) in Middle income?
Make the answer very short. 0.01. What is the difference between the highest and the second highest Rating (1=low 6=high) of South Asia?
Your answer should be very brief. 0.02. What is the difference between the highest and the second highest Rating (1=low 6=high) in Central African Republic?
Your answer should be very brief. 0. What is the difference between the highest and the second highest Rating (1=low 6=high) in Mauritania?
Offer a terse response. 0.5. What is the difference between the highest and the lowest Rating (1=low 6=high) of Middle income?
Make the answer very short. 0.09. What is the difference between the highest and the lowest Rating (1=low 6=high) of South Asia?
Your answer should be very brief. 0.19. What is the difference between the highest and the lowest Rating (1=low 6=high) in Central African Republic?
Your answer should be very brief. 0. What is the difference between the highest and the lowest Rating (1=low 6=high) of Mauritania?
Your response must be concise. 1. 